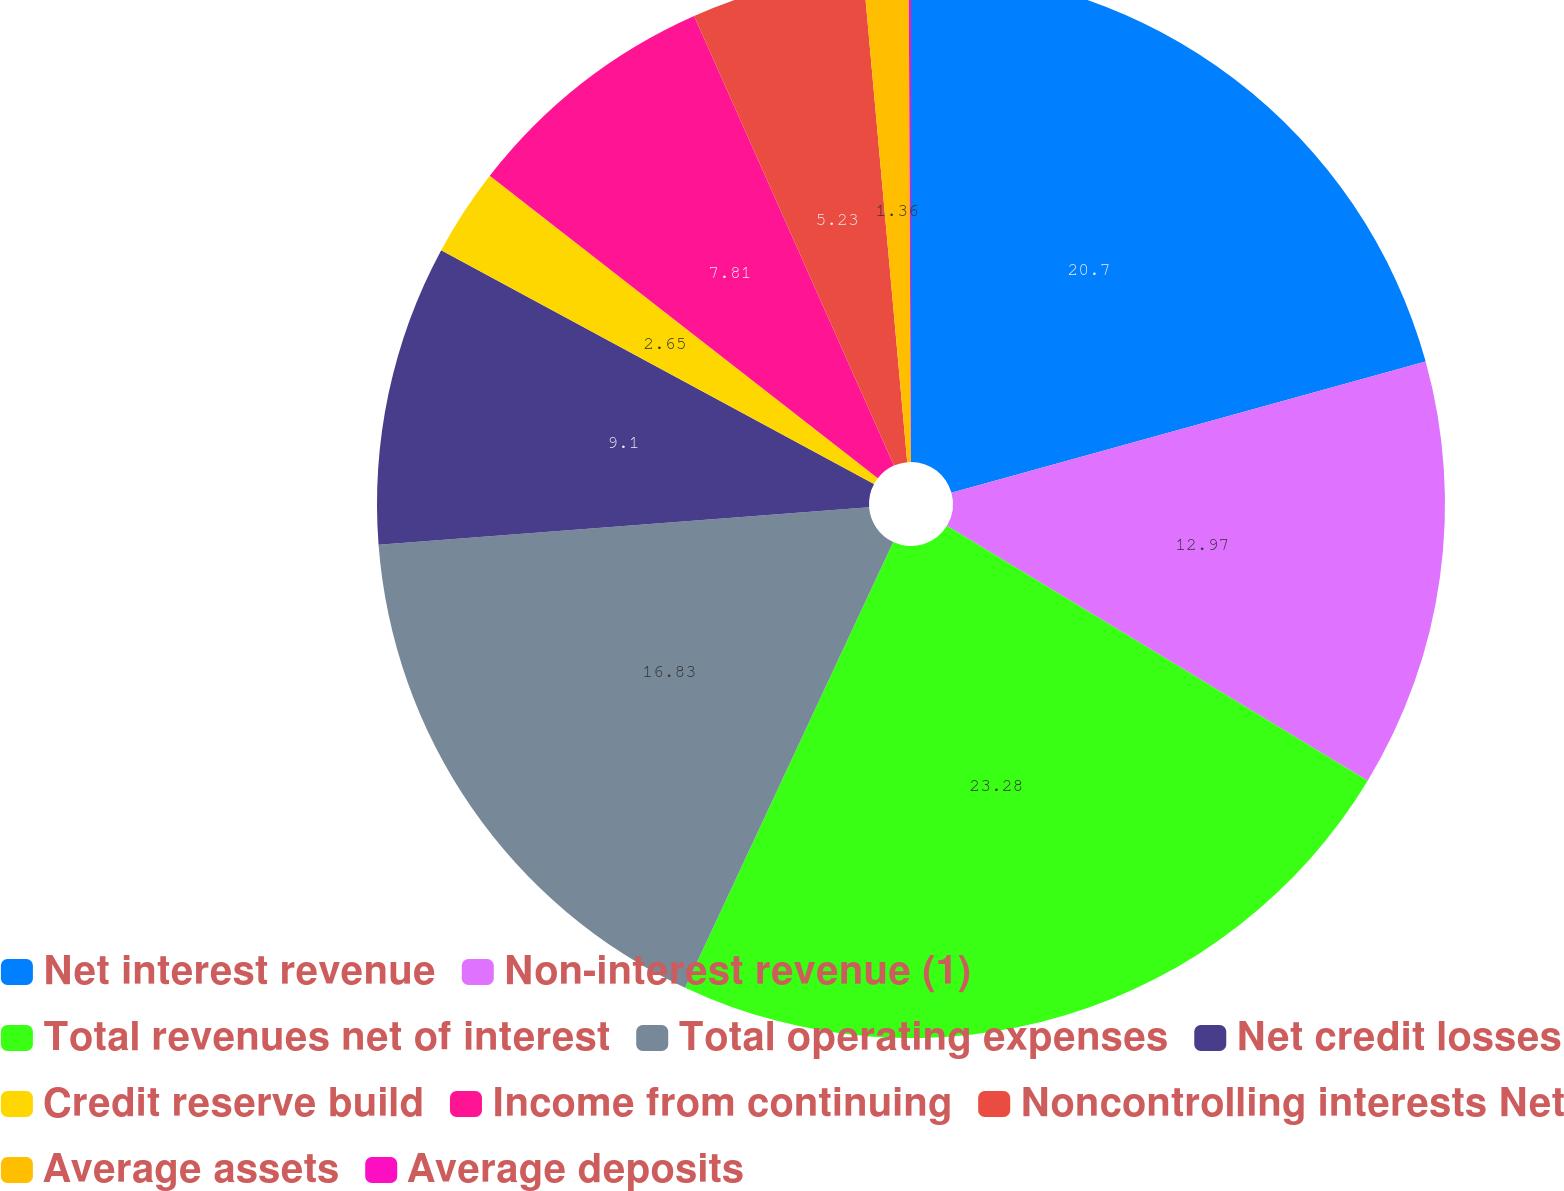<chart> <loc_0><loc_0><loc_500><loc_500><pie_chart><fcel>Net interest revenue<fcel>Non-interest revenue (1)<fcel>Total revenues net of interest<fcel>Total operating expenses<fcel>Net credit losses<fcel>Credit reserve build<fcel>Income from continuing<fcel>Noncontrolling interests Net<fcel>Average assets<fcel>Average deposits<nl><fcel>20.71%<fcel>12.97%<fcel>23.29%<fcel>16.84%<fcel>9.1%<fcel>2.65%<fcel>7.81%<fcel>5.23%<fcel>1.36%<fcel>0.07%<nl></chart> 